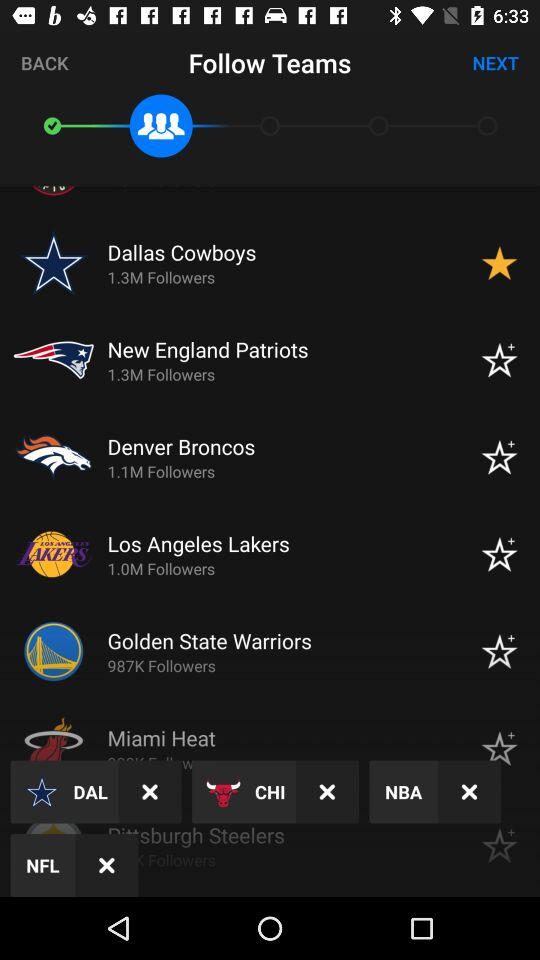How many followers do the Denver Broncos have? The Denver Broncos have 1.1 million followers. 